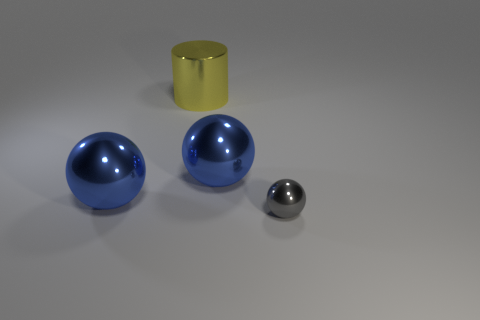Add 1 big green shiny objects. How many objects exist? 5 Subtract all cylinders. How many objects are left? 3 Add 2 cylinders. How many cylinders are left? 3 Add 1 large brown balls. How many large brown balls exist? 1 Subtract 0 purple cylinders. How many objects are left? 4 Subtract all cyan metal objects. Subtract all tiny gray spheres. How many objects are left? 3 